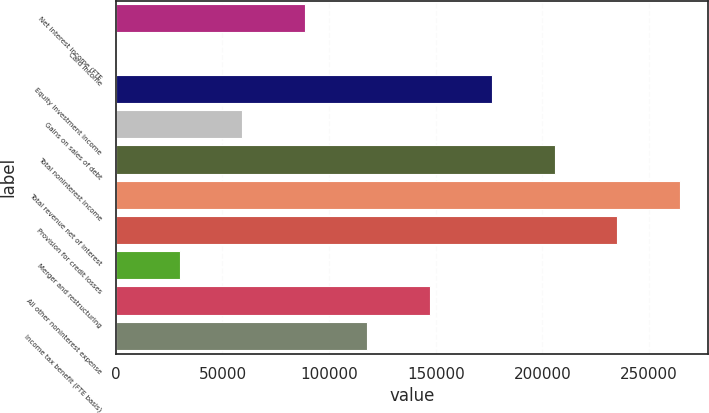Convert chart to OTSL. <chart><loc_0><loc_0><loc_500><loc_500><bar_chart><fcel>Net interest income (FTE<fcel>Card income<fcel>Equity investment income<fcel>Gains on sales of debt<fcel>Total noninterest income<fcel>Total revenue net of interest<fcel>Provision for credit losses<fcel>Merger and restructuring<fcel>All other noninterest expense<fcel>Income tax benefit (FTE basis)<nl><fcel>88503.6<fcel>615<fcel>176392<fcel>59207.4<fcel>205688<fcel>264281<fcel>234985<fcel>29911.2<fcel>147096<fcel>117800<nl></chart> 